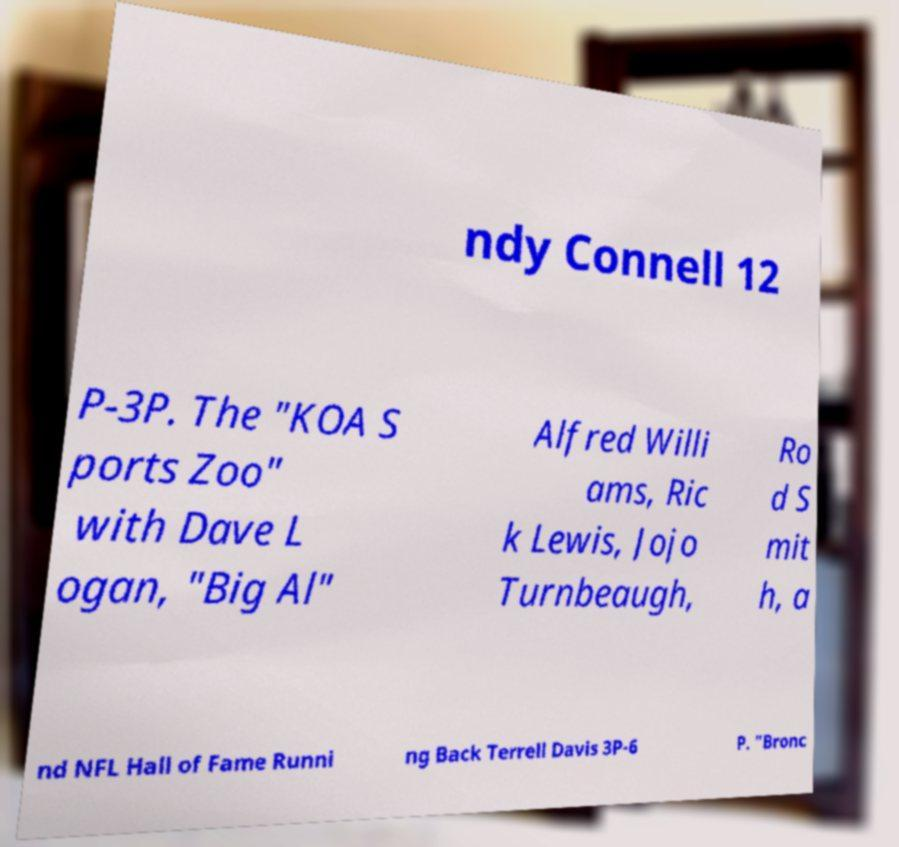Can you accurately transcribe the text from the provided image for me? ndy Connell 12 P-3P. The "KOA S ports Zoo" with Dave L ogan, "Big Al" Alfred Willi ams, Ric k Lewis, Jojo Turnbeaugh, Ro d S mit h, a nd NFL Hall of Fame Runni ng Back Terrell Davis 3P-6 P. "Bronc 